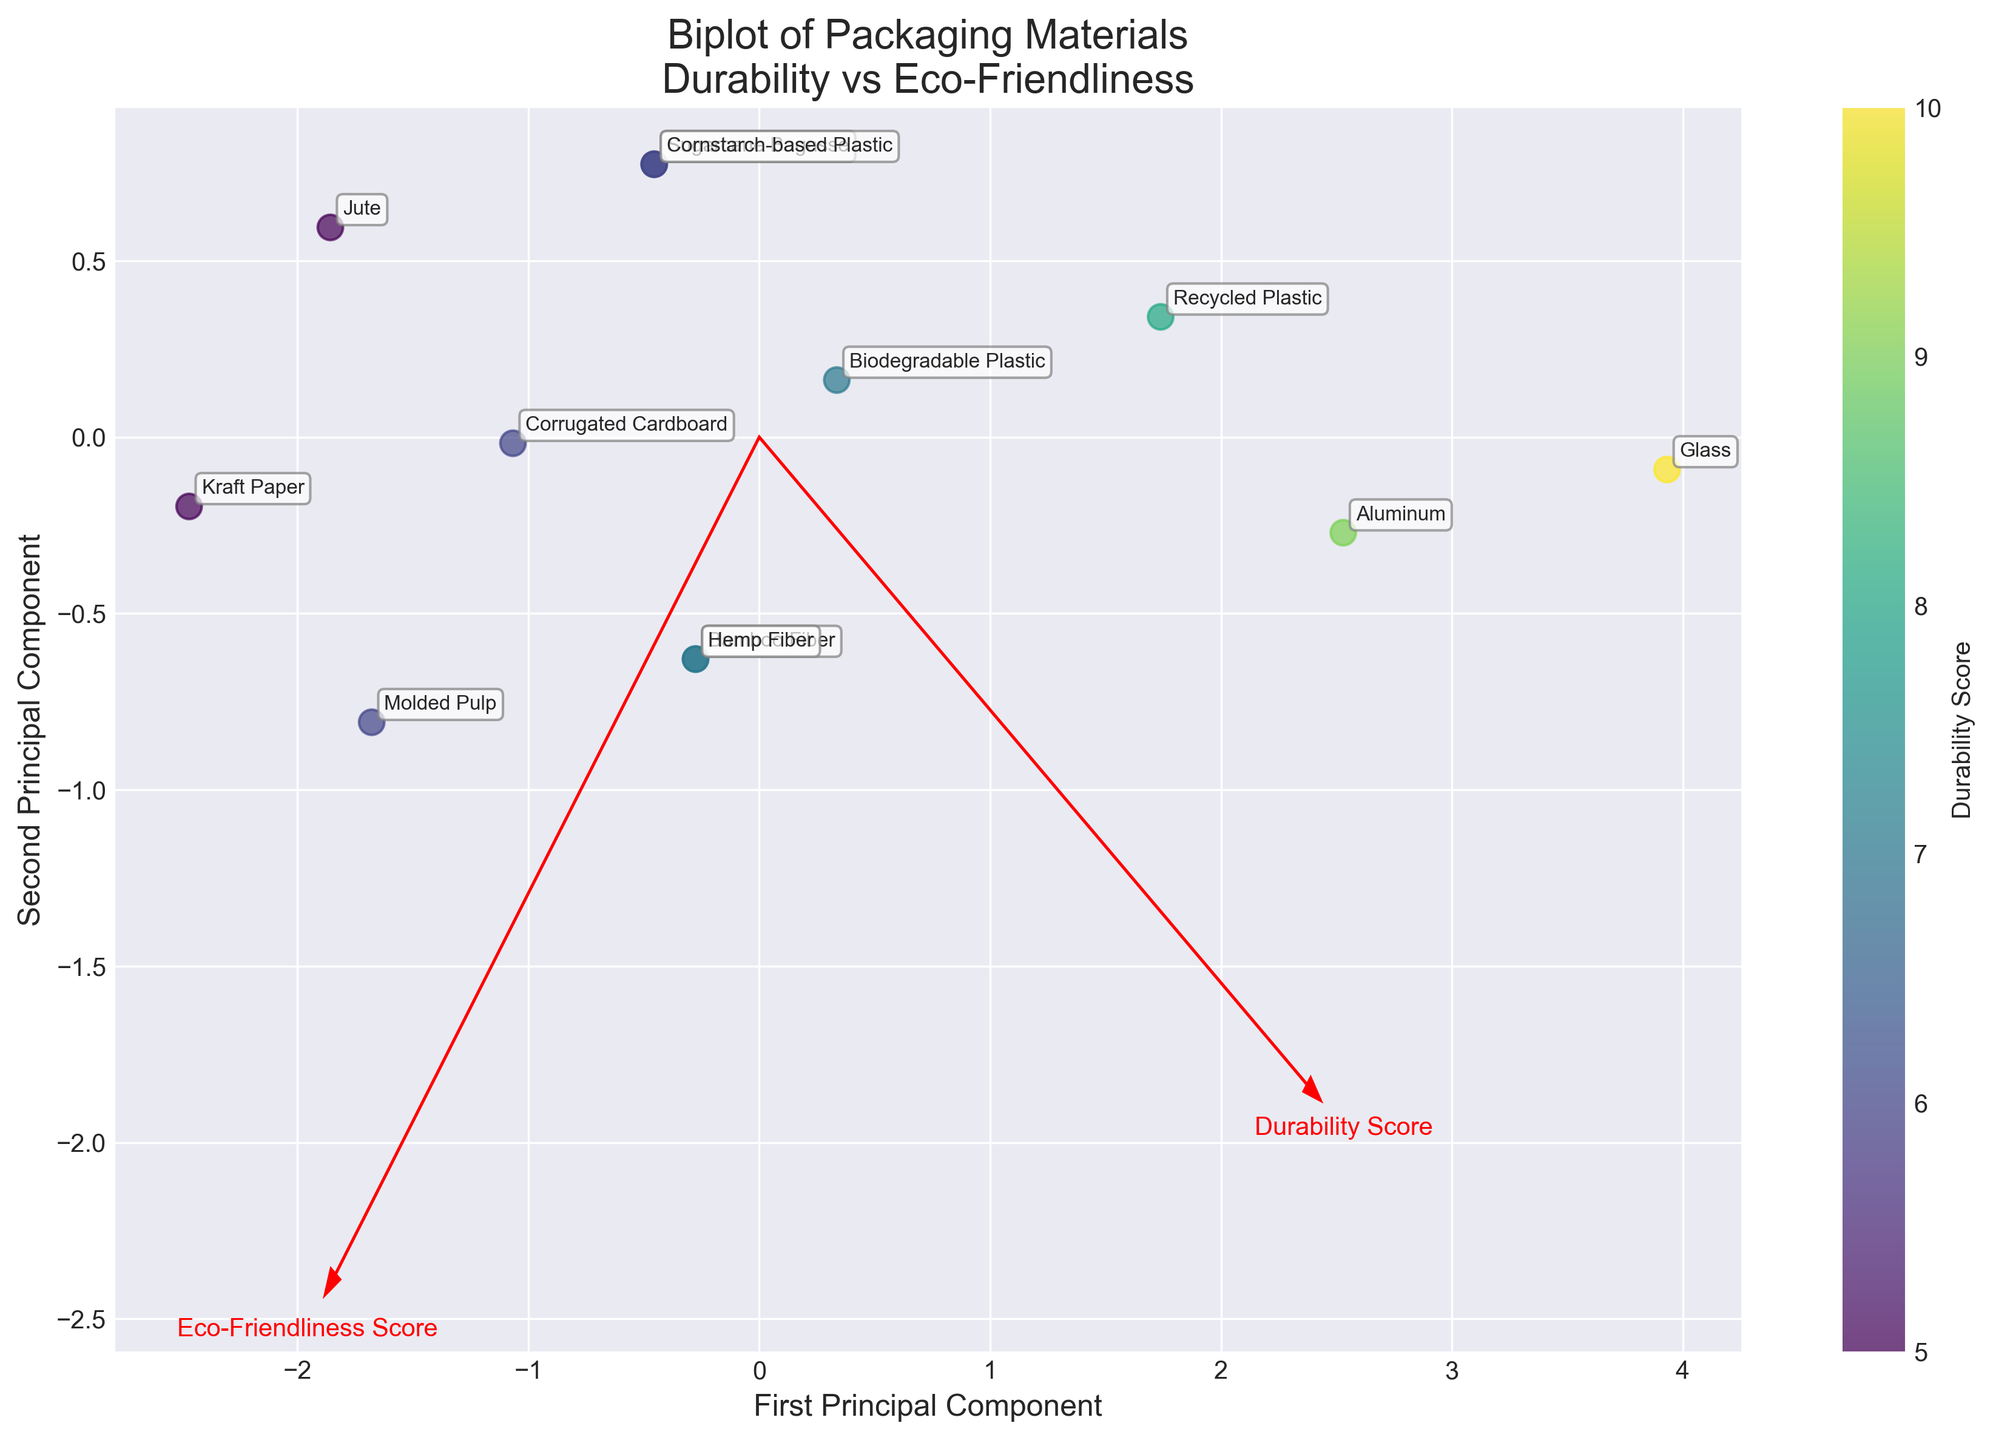What's the title of the figure? The title of the figure is displayed prominently at the top of the plot. It helps in understanding the primary focus of the biplot.
Answer: 'Biplot of Packaging Materials\nDurability vs Eco-Friendliness' How many materials are displayed on the biplot? The number of materials represented on the biplot is indicated by the number of labeled points. Each label corresponds to a different material from the data.
Answer: 12 Which material has the highest durability score? To determine the material with the highest durability score, look for the material plotted farthest to the left in the color scale since the color coding represents the durability score.
Answer: Glass Which material has the highest eco-friendliness score? The material with the highest eco-friendliness score can be found by identifying the label closest to the top of the second principal component axis.
Answer: Kraft Paper, Molded Pulp Which two materials have the exact same scores? Look for pairs of labels grouped closely together, indicating similar values in both components. If any two labels overlap or are very close, they likely have the same scores.
Answer: Bamboo Fiber and Hemp Fiber What is the relationship between durability and eco-friendliness in this biplot? Observing the general trend in the biplot, determine whether the durability scores of materials tend to increase or decrease with eco-friendliness scores or if any clear pattern emerges.
Answer: There is no clear linear relationship; durability can vary independently of eco-friendliness How does Recycled Plastic compare to Biodegradable Plastic in terms of both scores? Compare the relative positions of Recycled Plastic and Biodegradable Plastic in the biplot to understand their differences in durability and eco-friendliness scores.
Answer: Recycled Plastic has higher durability and lower eco-friendliness Which materials are closest to the origin on the biplot? Identifying the materials closest to the origin helps understand which materials have durability and eco-friendliness scores closest to the mean values.
Answer: Cornstarch-based Plastic, Sugarcane Bagasse, and Biodegradable Plastic How do the feature vectors (arrows) help in interpreting the biplot? Evaluate the direction and length of the feature vectors to understand how each principal component relates to the original variables (durability and eco-friendliness) in the data.
Answer: They show the direction of increasing durability and eco-friendliness scores, helping to interpret the axes Which material is an outlier in terms of both high durability and low eco-friendliness? Spot the label positioned farthest along one principal component but much lower on the other, representing it as an outlier in these aspects.
Answer: Glass 